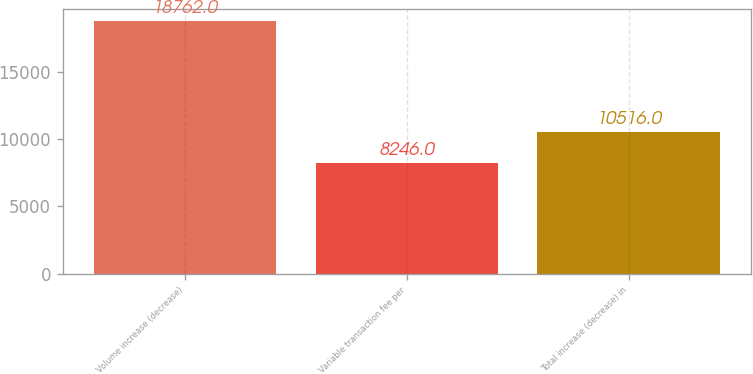<chart> <loc_0><loc_0><loc_500><loc_500><bar_chart><fcel>Volume increase (decrease)<fcel>Variable transaction fee per<fcel>Total increase (decrease) in<nl><fcel>18762<fcel>8246<fcel>10516<nl></chart> 